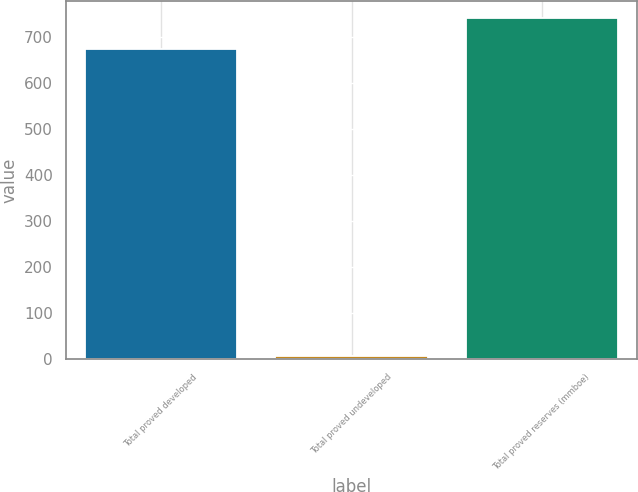Convert chart. <chart><loc_0><loc_0><loc_500><loc_500><bar_chart><fcel>Total proved developed<fcel>Total proved undeveloped<fcel>Total proved reserves (mmboe)<nl><fcel>674<fcel>6<fcel>741.4<nl></chart> 